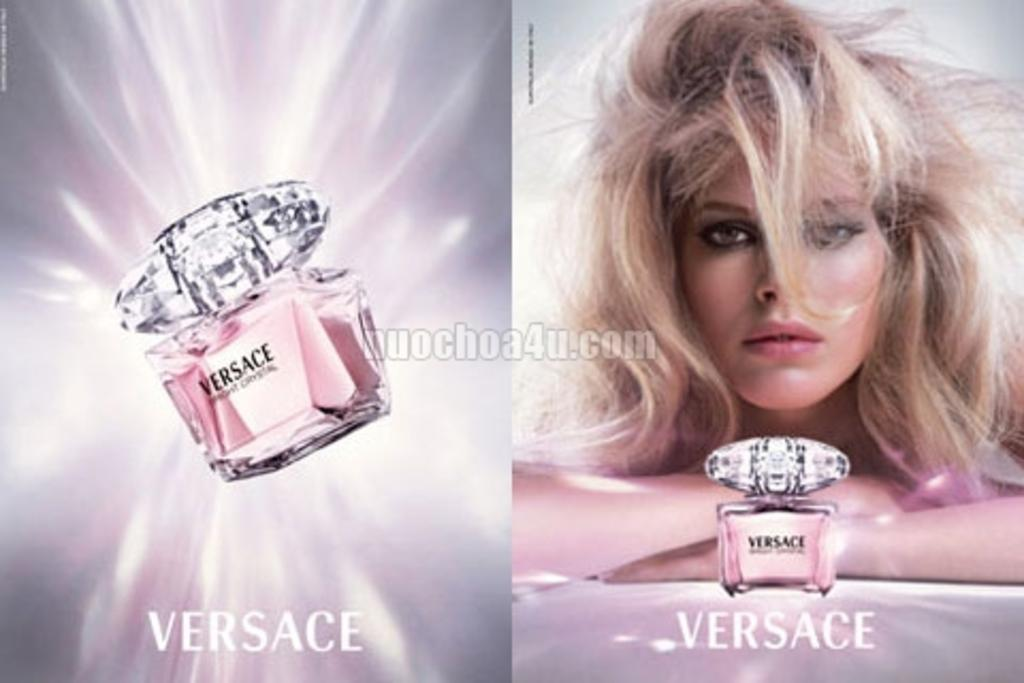<image>
Render a clear and concise summary of the photo. An ad for Versace shows a perfume bottle and a blond model. 